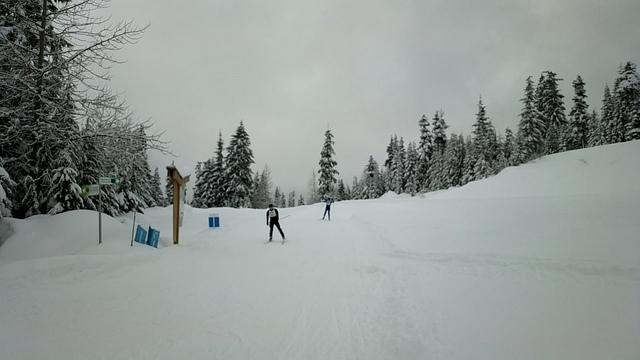What is the season?
Short answer required. Winter. Is the house on top of the hill?
Give a very brief answer. No. Is this person in the air?
Be succinct. No. Could this be cross-country skiing?
Short answer required. Yes. What are the weather conditions?
Concise answer only. Cold. Is there a boat in the picture?
Be succinct. No. What is that object in the far background?
Answer briefly. Trees. 